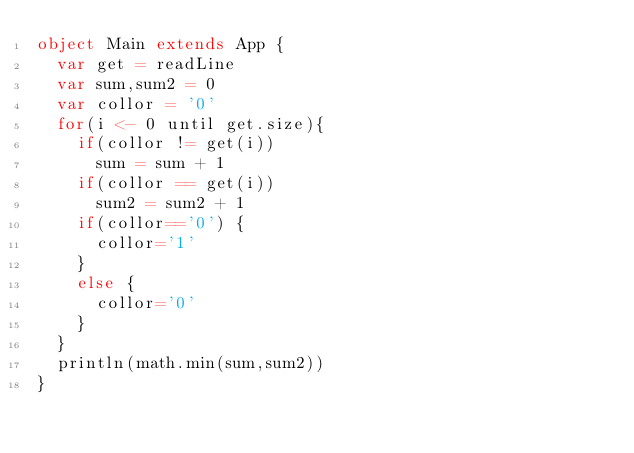Convert code to text. <code><loc_0><loc_0><loc_500><loc_500><_Scala_>object Main extends App {
  var get = readLine
  var sum,sum2 = 0
  var collor = '0'
  for(i <- 0 until get.size){
    if(collor != get(i))
    	sum = sum + 1
    if(collor == get(i))
    	sum2 = sum2 + 1
    if(collor=='0') {
      collor='1'
    }
    else {
      collor='0'
    }
  }
  println(math.min(sum,sum2))
}</code> 